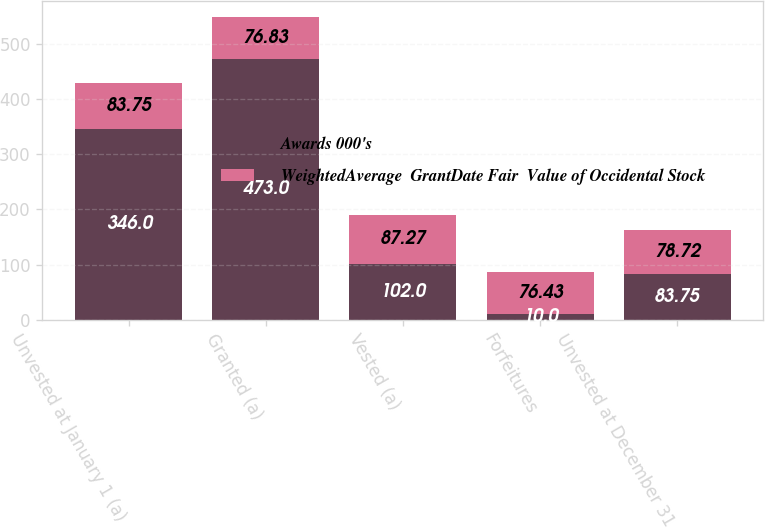Convert chart. <chart><loc_0><loc_0><loc_500><loc_500><stacked_bar_chart><ecel><fcel>Unvested at January 1 (a)<fcel>Granted (a)<fcel>Vested (a)<fcel>Forfeitures<fcel>Unvested at December 31<nl><fcel>Awards 000's<fcel>346<fcel>473<fcel>102<fcel>10<fcel>83.75<nl><fcel>WeightedAverage  GrantDate Fair  Value of Occidental Stock<fcel>83.75<fcel>76.83<fcel>87.27<fcel>76.43<fcel>78.72<nl></chart> 